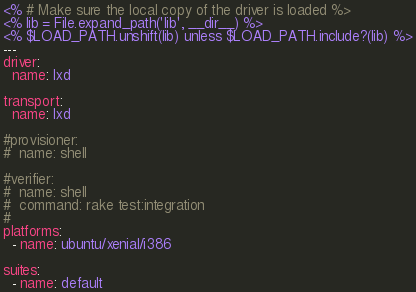<code> <loc_0><loc_0><loc_500><loc_500><_YAML_><% # Make sure the local copy of the driver is loaded %>
<% lib = File.expand_path('lib', __dir__) %>
<% $LOAD_PATH.unshift(lib) unless $LOAD_PATH.include?(lib) %>
---
driver:
  name: lxd

transport:
  name: lxd

#provisioner:
#  name: shell

#verifier:
#  name: shell
#  command: rake test:integration
#
platforms:
  - name: ubuntu/xenial/i386

suites:
  - name: default
</code> 